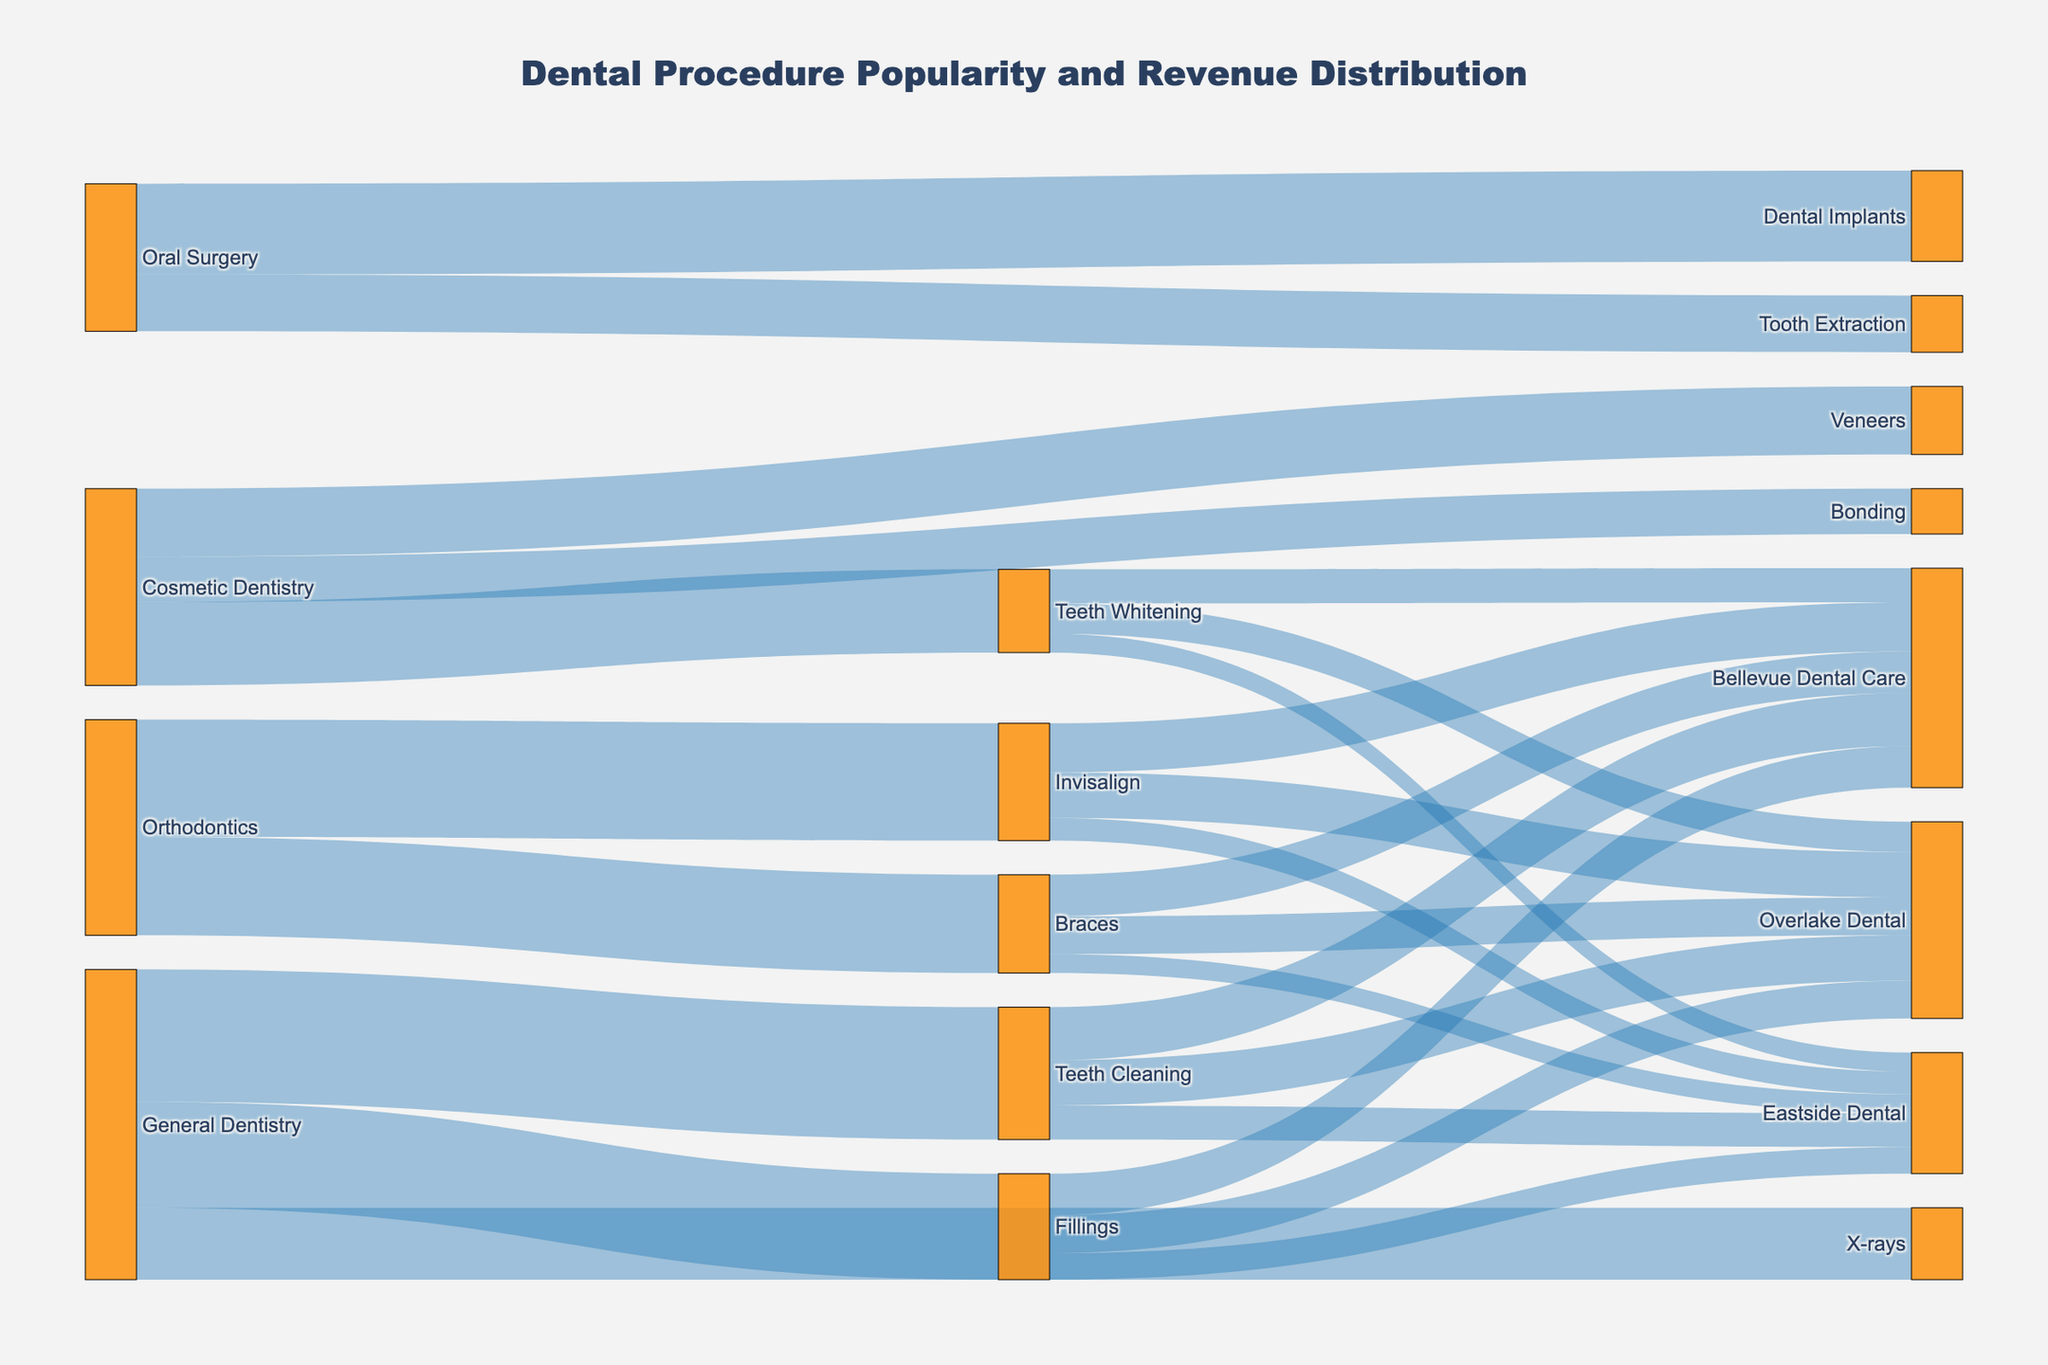what type of dental procedure generates the most revenue in Bellevue clinics? To find which dental procedure generates the most revenue, look at the node with the highest value on the left side of the diagram. In this case, Invisalign, an Orthodontics procedure, has the highest value.
Answer: Invisalign which clinic receives the most revenue from Braces procedures? Look at the 'Braces' node and follow the links to the clinics. The clinic with the highest value is Bellevue Dental Care.
Answer: Bellevue Dental Care how much total revenue does Overlake Dental generate from Teeth Cleaning and Fillings combined? Add the values of Teeth Cleaning and Fillings directed to Overlake Dental. Teeth Cleaning has 1200, and Fillings has 1000. Sum them up: 1200 + 1000 = 2200.
Answer: 2200 how is the revenue from Cosmetic Dentistry distributed among the procedures? Look at the Cosmetic Dentistry node and follow its outgoing links to see the values for each procedure: Teeth Whitening (2200), Veneers (1800), and Bonding (1200).
Answer: Teeth Whitening: 2200, Veneers: 1800, Bonding: 1200 what is the difference in revenue generated between General Dentistry and Oral Surgery? Sum the values for General Dentistry's procedures: Teeth Cleaning (3500) + Fillings (2800) + X-Rays (1900) = 8200. For Oral Surgery: Tooth Extraction (1500) + Dental Implants (2400) = 3900. The difference is 8200 - 3900 = 4300.
Answer: 4300 which general dentistry procedure is the least popular among all Bellevue clinics? Check the procedures under General Dentistry and compare their values. The least popular procedure is X-Rays with a value of 1900.
Answer: X-Rays which clinic has the least revenue from all listed procedures? Add up all the values directed towards each clinic and identify the smallest total. Eastside Dental: 900 (Teeth Cleaning) + 700 (Fillings) + 500 (Teeth Whitening) + 500 (Braces) + 600 (Invisalign) = 3200.
Answer: Eastside Dental how does the popularity of cosmetic dental procedures compare between Veneers and Bonding? For Cosmetic Dentistry, compare the values of Veneers (1800) and Bonding (1200). Veneers are more popular than Bonding.
Answer: Veneers are more popular than Bonding which clinic generates more revenue from Orthodontics procedures, Overlake Dental or Bellevue Dental Care? Compare the sum of Orthodontics procedures (Braces and Invisalign) for both clinics: Overlake Dental: Braces (1000) + Invisalign (1200) = 2200. Bellevue Dental Care: Braces (1100) + Invisalign (1300) = 2400. Bellevue Dental Care generates more.
Answer: Bellevue Dental Care generates more what is the total revenue generated from all procedures by Eastside Dental? Add up the revenue from all procedures directed to Eastside Dental: Teeth Cleaning (900) + Fillings (700) + Teeth Whitening (500) + Braces (500) + Invisalign (600) = 3200.
Answer: 3200 